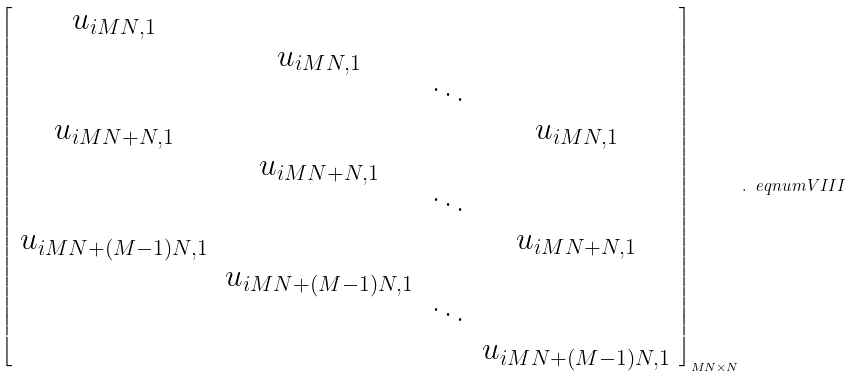Convert formula to latex. <formula><loc_0><loc_0><loc_500><loc_500>\left [ \begin{array} { c c c c } u _ { i M N , 1 } & & & \\ & u _ { i M N , 1 } & & \\ & & \ddots & \\ u _ { i M N + N , 1 } & & & u _ { i M N , 1 } \\ & u _ { i M N + N , 1 } & & \\ & & \ddots & \\ u _ { i M N + ( M - 1 ) N , 1 } & & & u _ { i M N + N , 1 } \\ & u _ { i M N + ( M - 1 ) N , 1 } & & \\ & & \ddots & \\ & & & u _ { i M N + ( M - 1 ) N , 1 } \end{array} \right ] _ { M N \times N } . \ e q n u m { V I I I }</formula> 